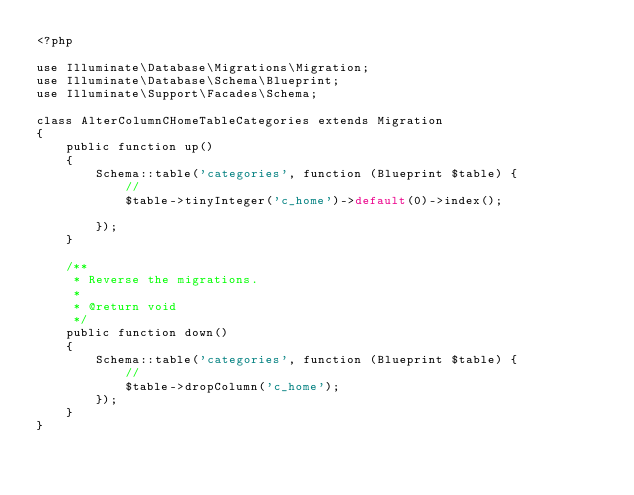<code> <loc_0><loc_0><loc_500><loc_500><_PHP_><?php

use Illuminate\Database\Migrations\Migration;
use Illuminate\Database\Schema\Blueprint;
use Illuminate\Support\Facades\Schema;

class AlterColumnCHomeTableCategories extends Migration
{
    public function up()
    {
        Schema::table('categories', function (Blueprint $table) {
            //
            $table->tinyInteger('c_home')->default(0)->index();
        
        });
    }

    /**
     * Reverse the migrations.
     *
     * @return void
     */
    public function down()
    {
        Schema::table('categories', function (Blueprint $table) {
            //
            $table->dropColumn('c_home');
        });
    }
}</code> 